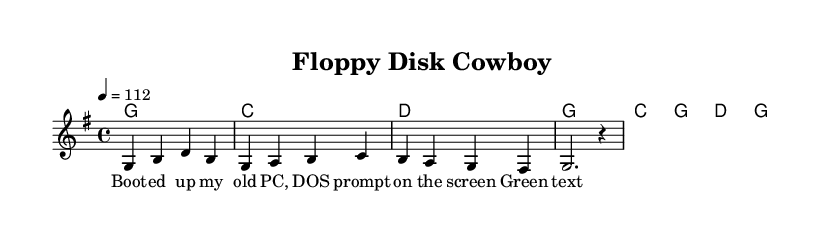What is the key signature of this music? The key signature is G major, which has one sharp (F#). This can be identified by looking at the key signature section at the beginning of the score.
Answer: G major What is the time signature of this music? The time signature is 4/4, which means there are four beats in each measure. This can be determined by the notation at the beginning of the score indicating the time signature.
Answer: 4/4 What is the tempo marking for this piece? The tempo marking indicates a speed of 112 beats per minute. This is shown in the score, where the tempo is specified near the beginning.
Answer: 112 How many measures does the chorus have? The chorus consists of four measures, which is evident by counting the number of measure bars in the chorus chords section.
Answer: 4 Which chords are used in the verse? The chords for the verse are G, C, D, G, determined by examining the chord symbols written above the lyric lines in that section of the music.
Answer: G, C, D What is a common theme in the lyrics? The lyrics reflect nostalgia for old computer systems, particularly mentioning DOS and the color scheme of green text on a black background, which conveys a sense of longing for the past in the context of technology.
Answer: Nostalgia What type of music does this piece represent? This piece represents Country Rock, as indicated by its blending of traditional country elements with rock music structure and instrumentation.
Answer: Country Rock 